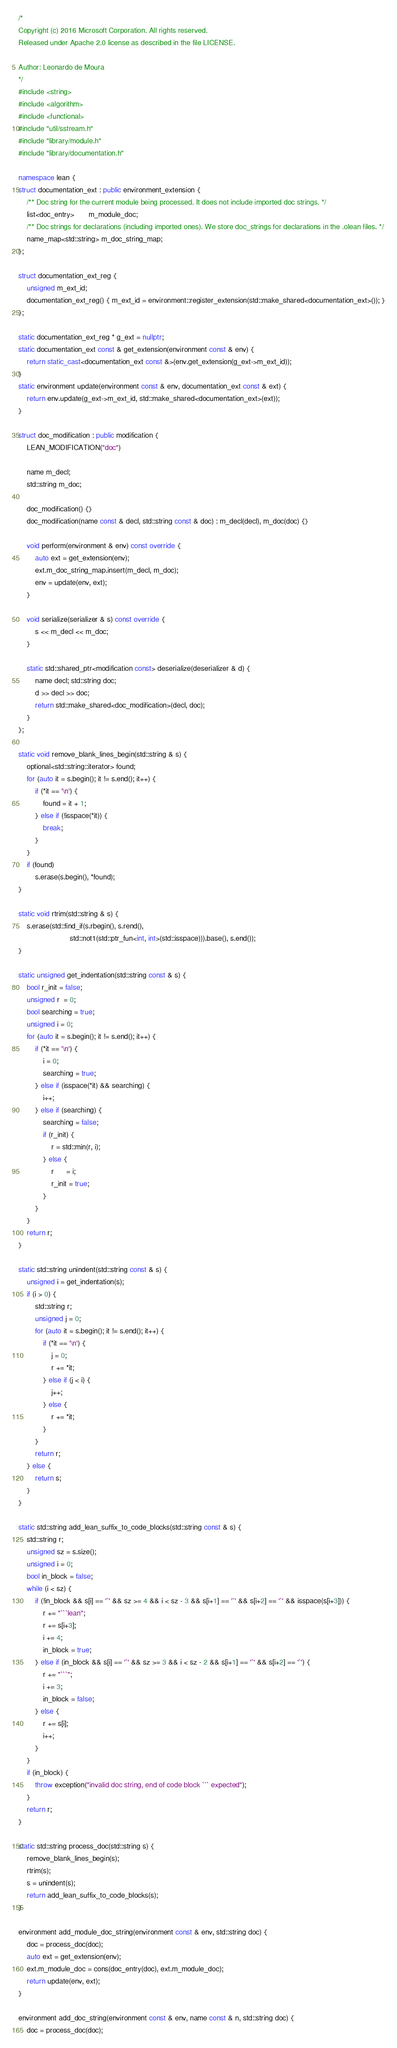<code> <loc_0><loc_0><loc_500><loc_500><_C++_>/*
Copyright (c) 2016 Microsoft Corporation. All rights reserved.
Released under Apache 2.0 license as described in the file LICENSE.

Author: Leonardo de Moura
*/
#include <string>
#include <algorithm>
#include <functional>
#include "util/sstream.h"
#include "library/module.h"
#include "library/documentation.h"

namespace lean {
struct documentation_ext : public environment_extension {
    /** Doc string for the current module being processed. It does not include imported doc strings. */
    list<doc_entry>       m_module_doc;
    /** Doc strings for declarations (including imported ones). We store doc_strings for declarations in the .olean files. */
    name_map<std::string> m_doc_string_map;
};

struct documentation_ext_reg {
    unsigned m_ext_id;
    documentation_ext_reg() { m_ext_id = environment::register_extension(std::make_shared<documentation_ext>()); }
};

static documentation_ext_reg * g_ext = nullptr;
static documentation_ext const & get_extension(environment const & env) {
    return static_cast<documentation_ext const &>(env.get_extension(g_ext->m_ext_id));
}
static environment update(environment const & env, documentation_ext const & ext) {
    return env.update(g_ext->m_ext_id, std::make_shared<documentation_ext>(ext));
}

struct doc_modification : public modification {
    LEAN_MODIFICATION("doc")

    name m_decl;
    std::string m_doc;

    doc_modification() {}
    doc_modification(name const & decl, std::string const & doc) : m_decl(decl), m_doc(doc) {}

    void perform(environment & env) const override {
        auto ext = get_extension(env);
        ext.m_doc_string_map.insert(m_decl, m_doc);
        env = update(env, ext);
    }

    void serialize(serializer & s) const override {
        s << m_decl << m_doc;
    }

    static std::shared_ptr<modification const> deserialize(deserializer & d) {
        name decl; std::string doc;
        d >> decl >> doc;
        return std::make_shared<doc_modification>(decl, doc);
    }
};

static void remove_blank_lines_begin(std::string & s) {
    optional<std::string::iterator> found;
    for (auto it = s.begin(); it != s.end(); it++) {
        if (*it == '\n') {
            found = it + 1;
        } else if (!isspace(*it)) {
            break;
        }
    }
    if (found)
        s.erase(s.begin(), *found);
}

static void rtrim(std::string & s) {
    s.erase(std::find_if(s.rbegin(), s.rend(),
                         std::not1(std::ptr_fun<int, int>(std::isspace))).base(), s.end());
}

static unsigned get_indentation(std::string const & s) {
    bool r_init = false;
    unsigned r  = 0;
    bool searching = true;
    unsigned i = 0;
    for (auto it = s.begin(); it != s.end(); it++) {
        if (*it == '\n') {
            i = 0;
            searching = true;
        } else if (isspace(*it) && searching) {
            i++;
        } else if (searching) {
            searching = false;
            if (r_init) {
                r = std::min(r, i);
            } else {
                r      = i;
                r_init = true;
            }
        }
    }
    return r;
}

static std::string unindent(std::string const & s) {
    unsigned i = get_indentation(s);
    if (i > 0) {
        std::string r;
        unsigned j = 0;
        for (auto it = s.begin(); it != s.end(); it++) {
            if (*it == '\n') {
                j = 0;
                r += *it;
            } else if (j < i) {
                j++;
            } else {
                r += *it;
            }
        }
        return r;
    } else {
        return s;
    }
}

static std::string add_lean_suffix_to_code_blocks(std::string const & s) {
    std::string r;
    unsigned sz = s.size();
    unsigned i = 0;
    bool in_block = false;
    while (i < sz) {
        if (!in_block && s[i] == '`' && sz >= 4 && i < sz - 3 && s[i+1] == '`' && s[i+2] == '`' && isspace(s[i+3])) {
            r += "```lean";
            r += s[i+3];
            i += 4;
            in_block = true;
        } else if (in_block && s[i] == '`' && sz >= 3 && i < sz - 2 && s[i+1] == '`' && s[i+2] == '`') {
            r += "```";
            i += 3;
            in_block = false;
        } else {
            r += s[i];
            i++;
        }
    }
    if (in_block) {
        throw exception("invalid doc string, end of code block ``` expected");
    }
    return r;
}

static std::string process_doc(std::string s) {
    remove_blank_lines_begin(s);
    rtrim(s);
    s = unindent(s);
    return add_lean_suffix_to_code_blocks(s);
}

environment add_module_doc_string(environment const & env, std::string doc) {
    doc = process_doc(doc);
    auto ext = get_extension(env);
    ext.m_module_doc = cons(doc_entry(doc), ext.m_module_doc);
    return update(env, ext);
}

environment add_doc_string(environment const & env, name const & n, std::string doc) {
    doc = process_doc(doc);</code> 